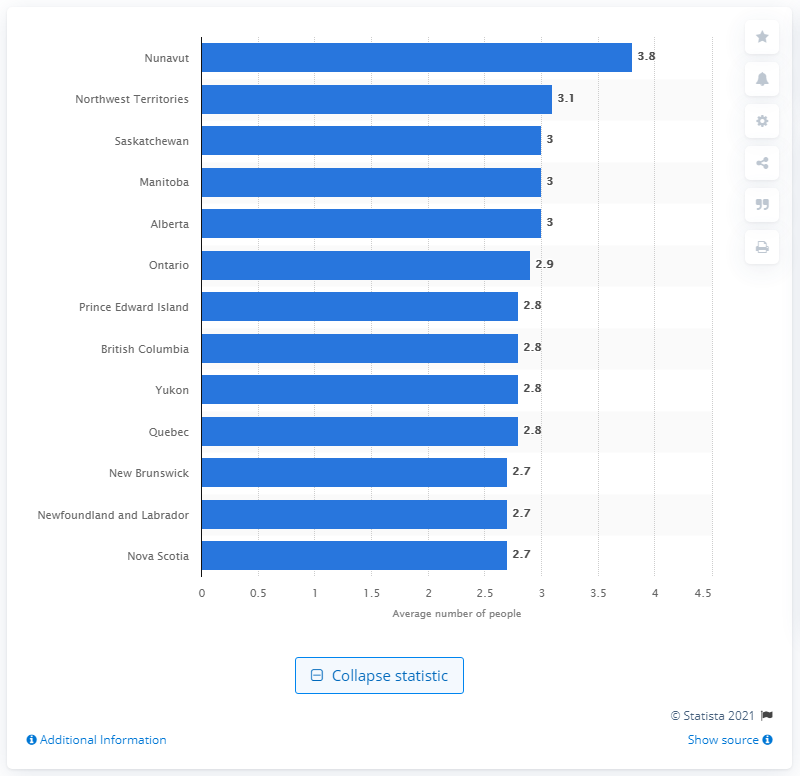Give some essential details in this illustration. In 2018, the average family size in Nunavut was 3.8. In 2018, the average number of people per family in Canada was 2.9. 